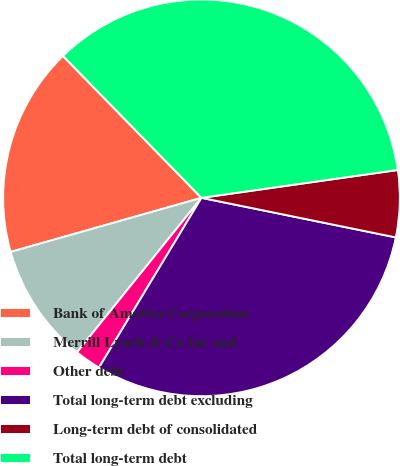Convert chart to OTSL. <chart><loc_0><loc_0><loc_500><loc_500><pie_chart><fcel>Bank of America Corporation<fcel>Merrill Lynch & Co Inc and<fcel>Other debt<fcel>Total long-term debt excluding<fcel>Long-term debt of consolidated<fcel>Total long-term debt<nl><fcel>17.09%<fcel>9.81%<fcel>2.15%<fcel>30.45%<fcel>5.44%<fcel>35.07%<nl></chart> 